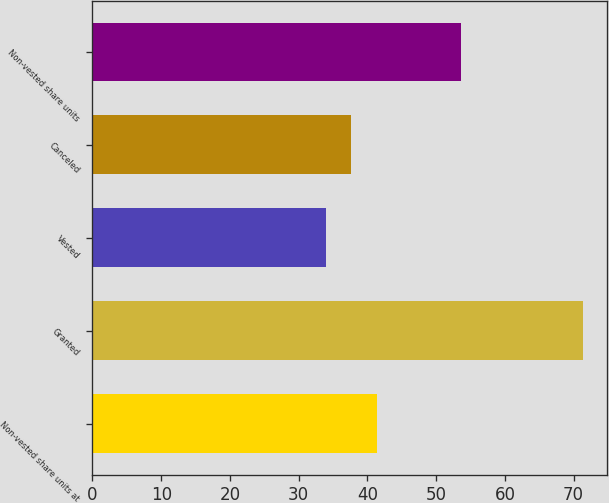<chart> <loc_0><loc_0><loc_500><loc_500><bar_chart><fcel>Non-vested share units at<fcel>Granted<fcel>Vested<fcel>Canceled<fcel>Non-vested share units<nl><fcel>41.42<fcel>71.36<fcel>33.94<fcel>37.68<fcel>53.57<nl></chart> 